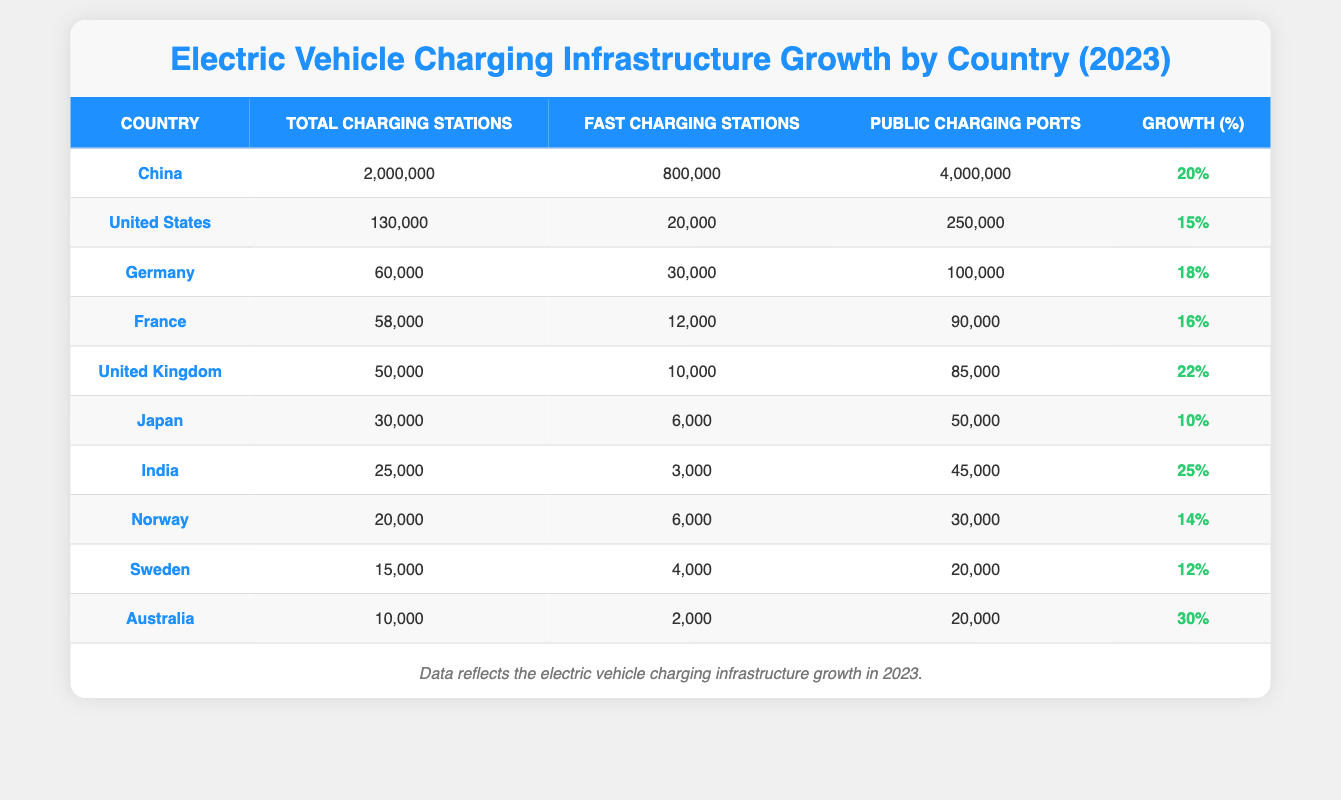What country has the highest number of total charging stations? From the table, China has 2,000,000 total charging stations, which is the highest among all listed countries.
Answer: China Which country has the lowest percentage growth in charging stations? By reviewing the growth percentages in the table, Japan has the lowest percentage growth at 10%.
Answer: Japan What is the total number of fast charging stations across the top three countries? The top three countries are China (800,000), the United States (20,000), and Germany (30,000). Adding these gives 800,000 + 20,000 + 30,000 = 850,000 fast charging stations.
Answer: 850,000 Is it true that the United Kingdom has more total charging stations than Germany? The table shows that the United Kingdom has 50,000 total charging stations, while Germany has 60,000, making the statement false.
Answer: False What is the percentage growth difference between India and Australia? India has a percentage growth of 25%, while Australia has 30%. The difference is calculated as 30% - 25% = 5%.
Answer: 5% In which country does the number of public charging ports exceed twice the number of total charging stations? From the table, China has 4,000,000 public charging ports, while its total charging stations are 2,000,000. 4,000,000 is indeed more than twice 2,000,000, so China qualifies.
Answer: China What is the average percentage growth of charging stations for the countries listed? First, we need to sum the percentage growths for all countries: 15 + 20 + 18 + 22 + 16 + 10 + 25 + 14 + 12 + 30 = 192. Then, dividing by 10 (the number of countries), the average percentage growth is 192 / 10 = 19.2%.
Answer: 19.2% Which country has the highest ratio of total charging stations to public charging ports? Calculating the ratios: for the United States, it’s 130,000/250,000 = 0.52; China: 2,000,000/4,000,000 = 0.5; Germany: 60,000/100,000 = 0.6; and so on. Germany has the highest ratio at 0.6.
Answer: Germany Total the number of fast charging stations for countries with over 30,000 total charging stations. The countries are China (800,000), the United States (20,000), Germany (30,000), and France (12,000). Adding these totals gives 800,000 + 20,000 + 30,000 + 12,000 = 862,000 fast charging stations.
Answer: 862,000 Is the total number of public charging ports in Norway less than 20,000? The table indicates Norway has 30,000 public charging ports, which is greater than 20,000, making the statement false.
Answer: False 